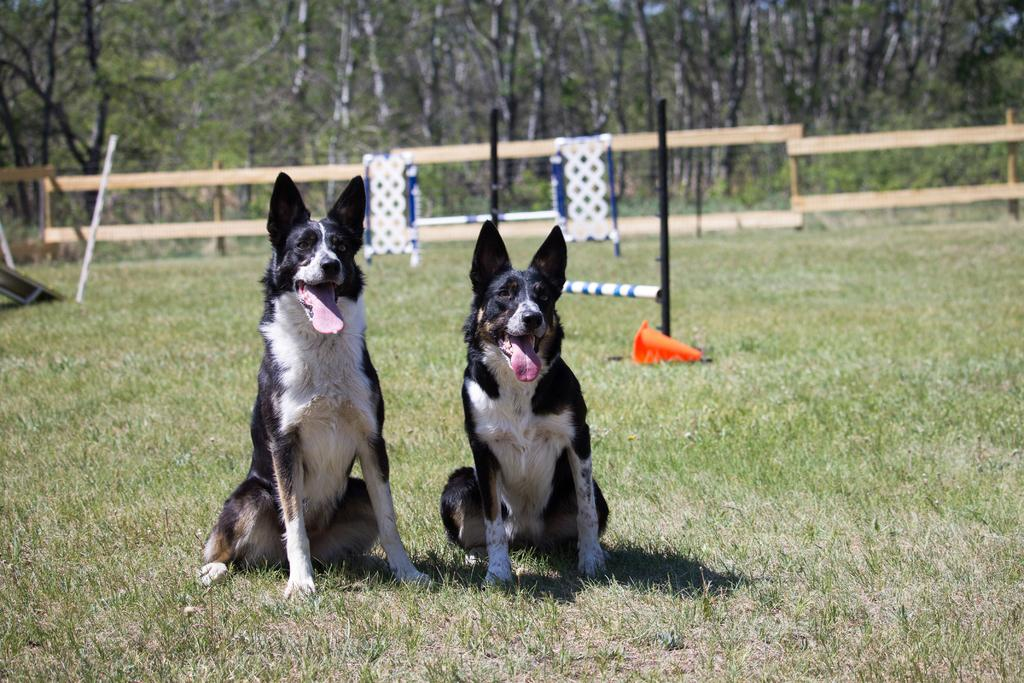How many dogs are present in the image? There are two dogs in the image. What is the fence used for in the image? The fence is likely used to separate or enclose an area in the image. What is the purpose of the traffic cone in the image? The traffic cone may be used to indicate a hazard or to direct traffic in the image. What type of vegetation can be seen in the image? Trees and plants are visible in the image. What direction is the creator of the image facing? There is no information about the creator of the image, so we cannot determine the direction they are facing. 